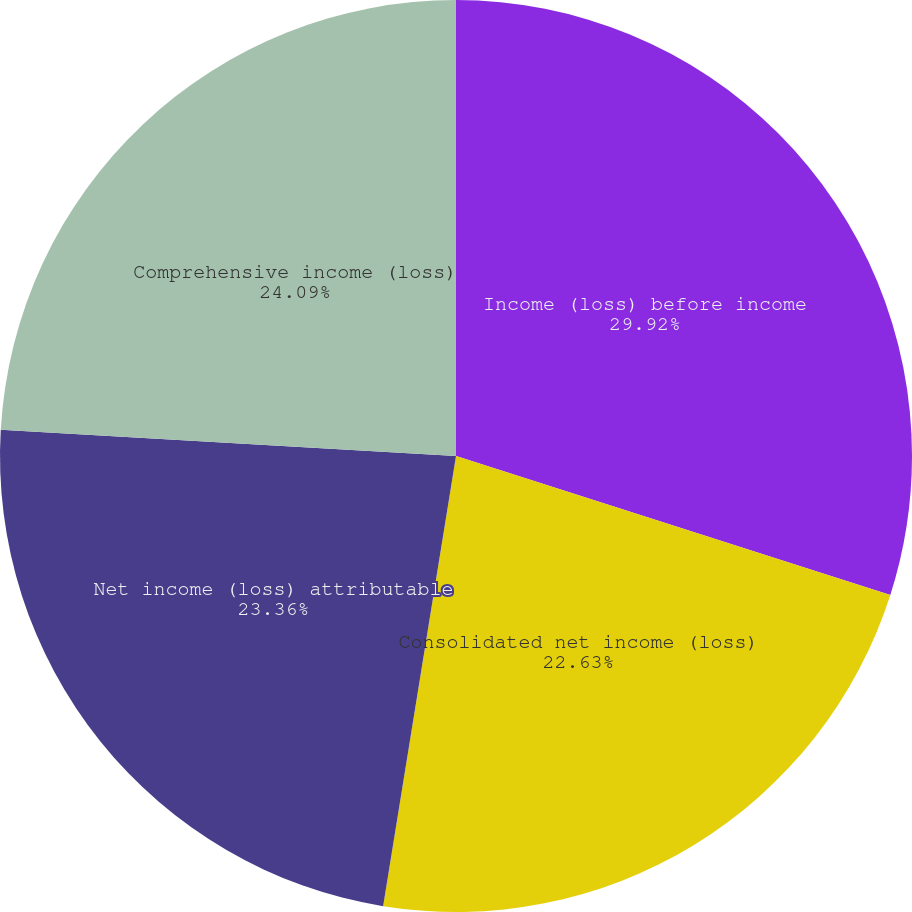Convert chart to OTSL. <chart><loc_0><loc_0><loc_500><loc_500><pie_chart><fcel>Income (loss) before income<fcel>Consolidated net income (loss)<fcel>Net income (loss) attributable<fcel>Comprehensive income (loss)<nl><fcel>29.93%<fcel>22.63%<fcel>23.36%<fcel>24.09%<nl></chart> 